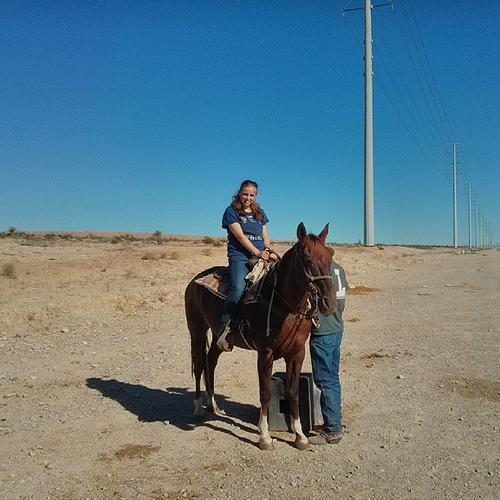How many horses are pictured?
Give a very brief answer. 1. 